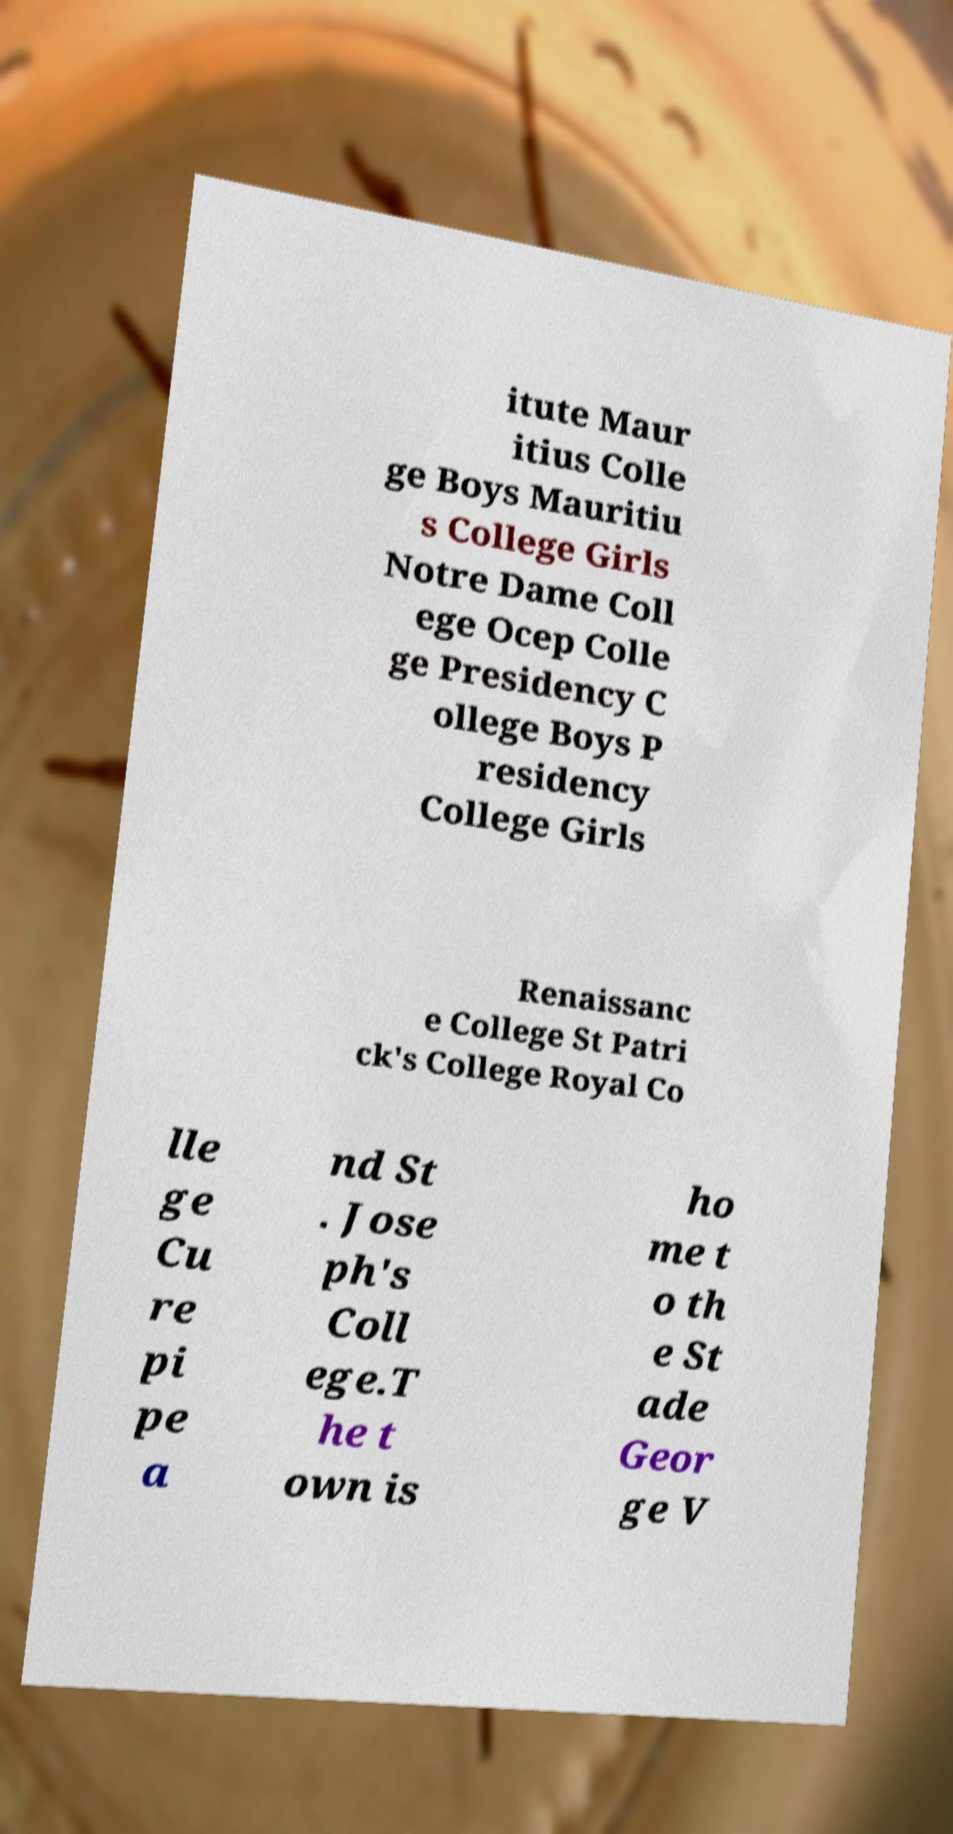For documentation purposes, I need the text within this image transcribed. Could you provide that? itute Maur itius Colle ge Boys Mauritiu s College Girls Notre Dame Coll ege Ocep Colle ge Presidency C ollege Boys P residency College Girls Renaissanc e College St Patri ck's College Royal Co lle ge Cu re pi pe a nd St . Jose ph's Coll ege.T he t own is ho me t o th e St ade Geor ge V 